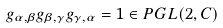<formula> <loc_0><loc_0><loc_500><loc_500>g _ { \alpha , \beta } \/ g _ { \beta , \gamma } \/ g _ { \gamma , \alpha } = 1 \in P G L ( 2 , { C } )</formula> 